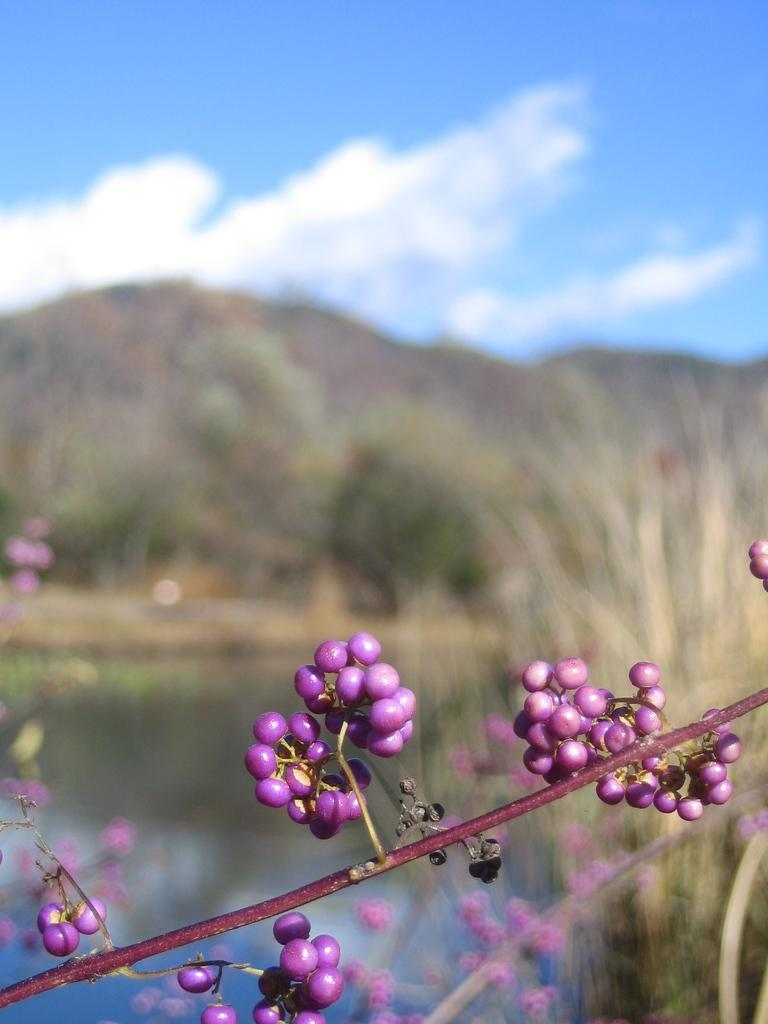What type of plant is depicted in the image? There is a part of a stem with fruits in the image. What is the setting of the image? The image shows a water surface, grass, hills, and the sky. Can you describe the sky in the image? The sky is visible in the image, and clouds are present. How many sticks are visible in the image? There are no sticks present in the image. What type of mineral can be seen in the image? There is no mineral, such as quartz, present in the image. 